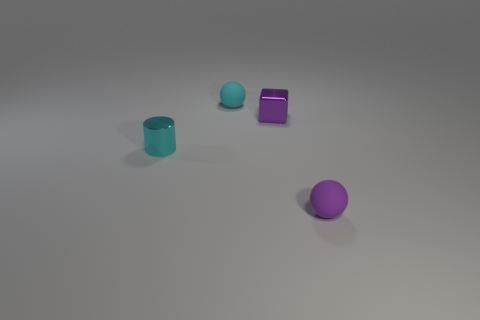Add 3 small purple matte spheres. How many objects exist? 7 Subtract all red objects. Subtract all cyan spheres. How many objects are left? 3 Add 2 cyan spheres. How many cyan spheres are left? 3 Add 1 cyan cylinders. How many cyan cylinders exist? 2 Subtract 0 blue cylinders. How many objects are left? 4 